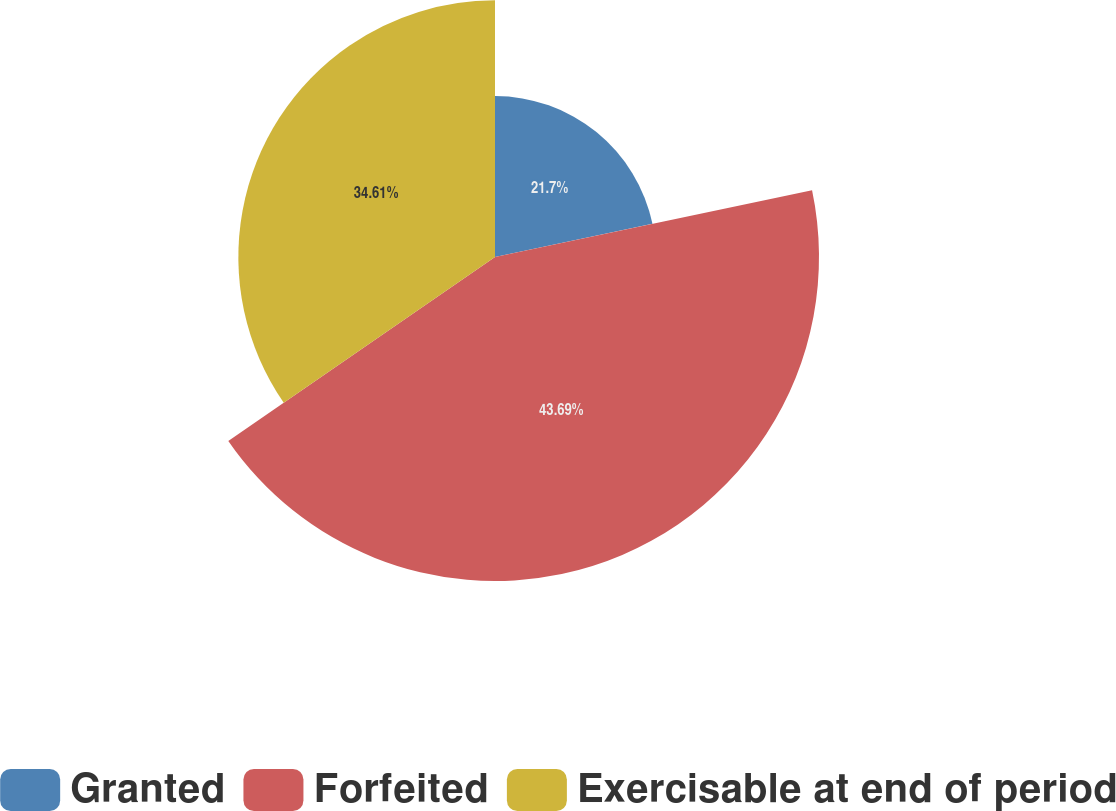<chart> <loc_0><loc_0><loc_500><loc_500><pie_chart><fcel>Granted<fcel>Forfeited<fcel>Exercisable at end of period<nl><fcel>21.7%<fcel>43.69%<fcel>34.61%<nl></chart> 